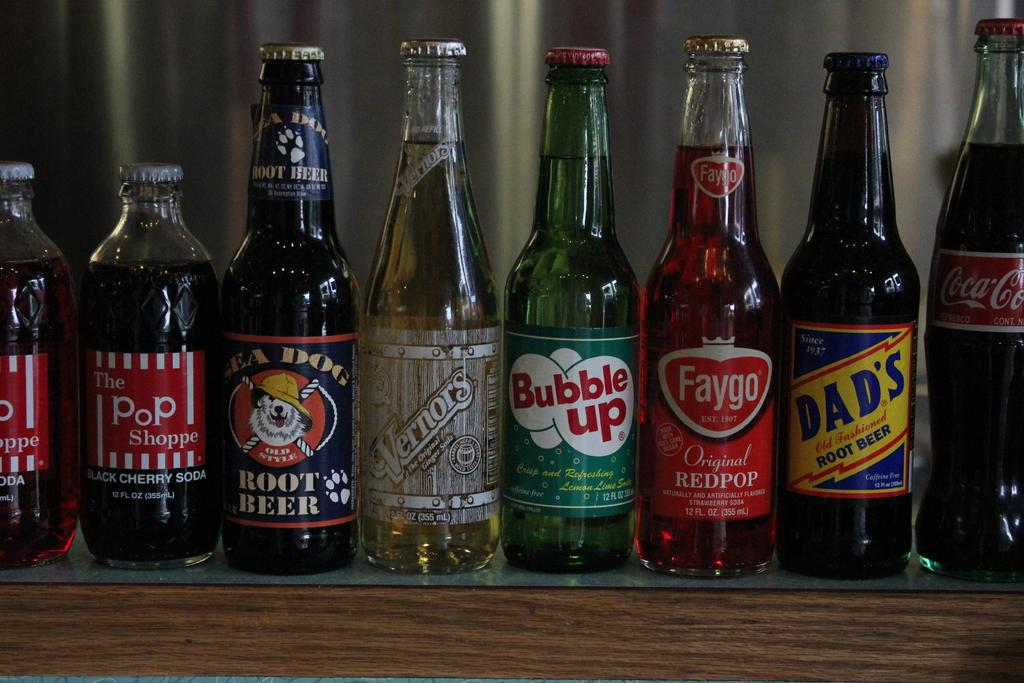Provide a one-sentence caption for the provided image. A line up of pop bottles on a shelf Bubble up is in the center. 